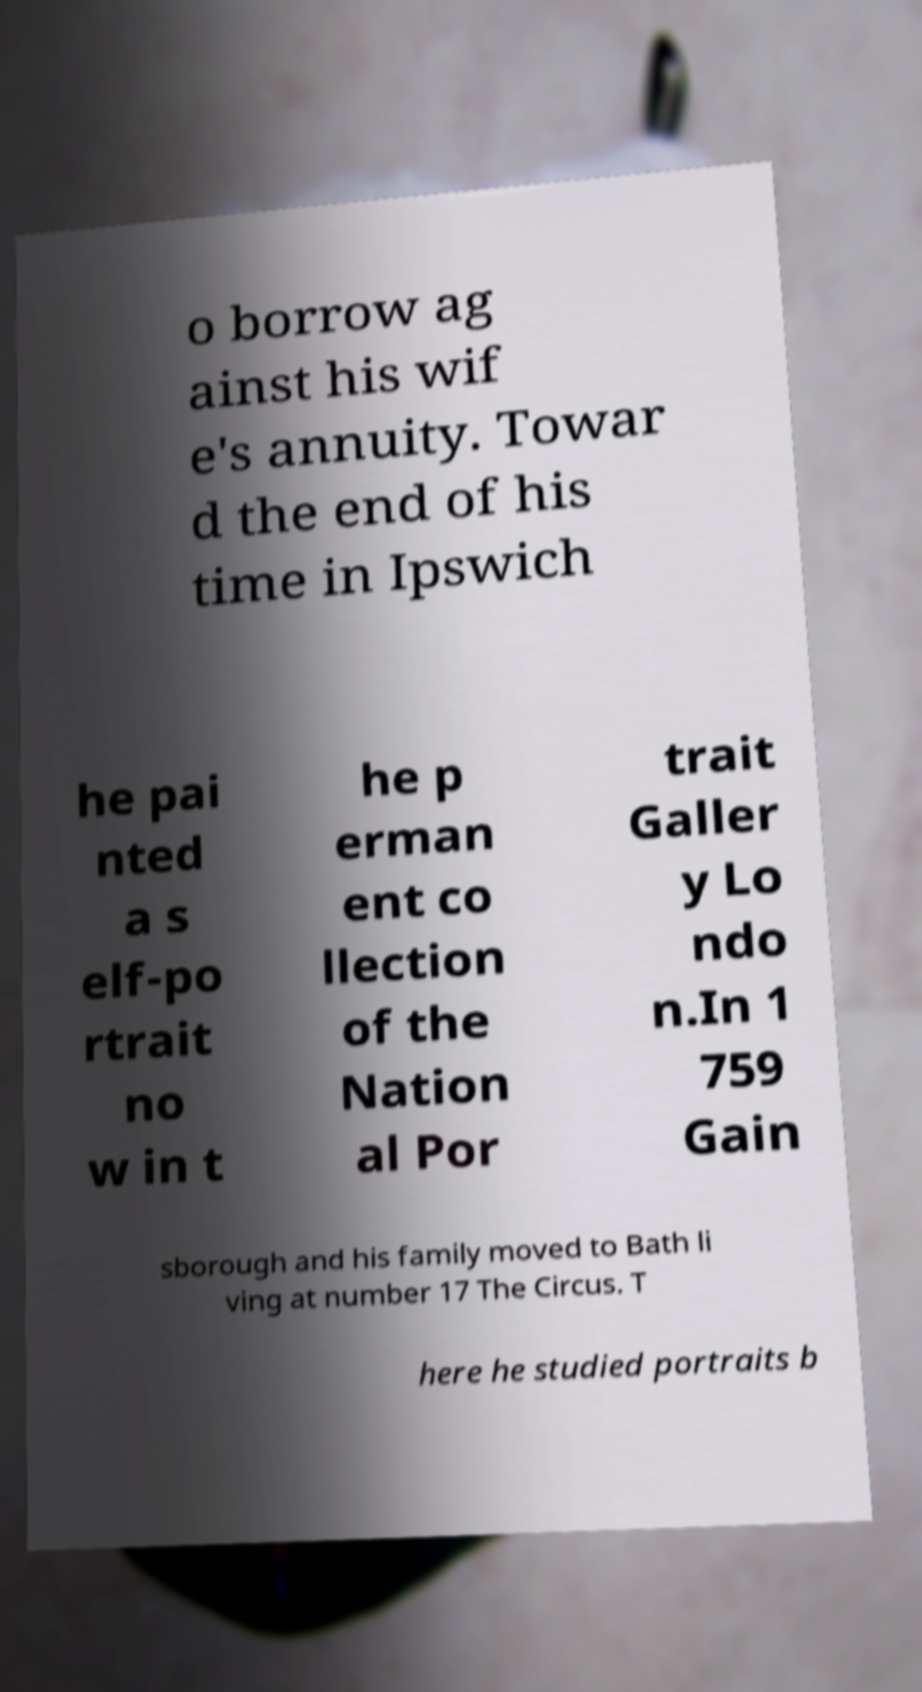Could you assist in decoding the text presented in this image and type it out clearly? o borrow ag ainst his wif e's annuity. Towar d the end of his time in Ipswich he pai nted a s elf-po rtrait no w in t he p erman ent co llection of the Nation al Por trait Galler y Lo ndo n.In 1 759 Gain sborough and his family moved to Bath li ving at number 17 The Circus. T here he studied portraits b 